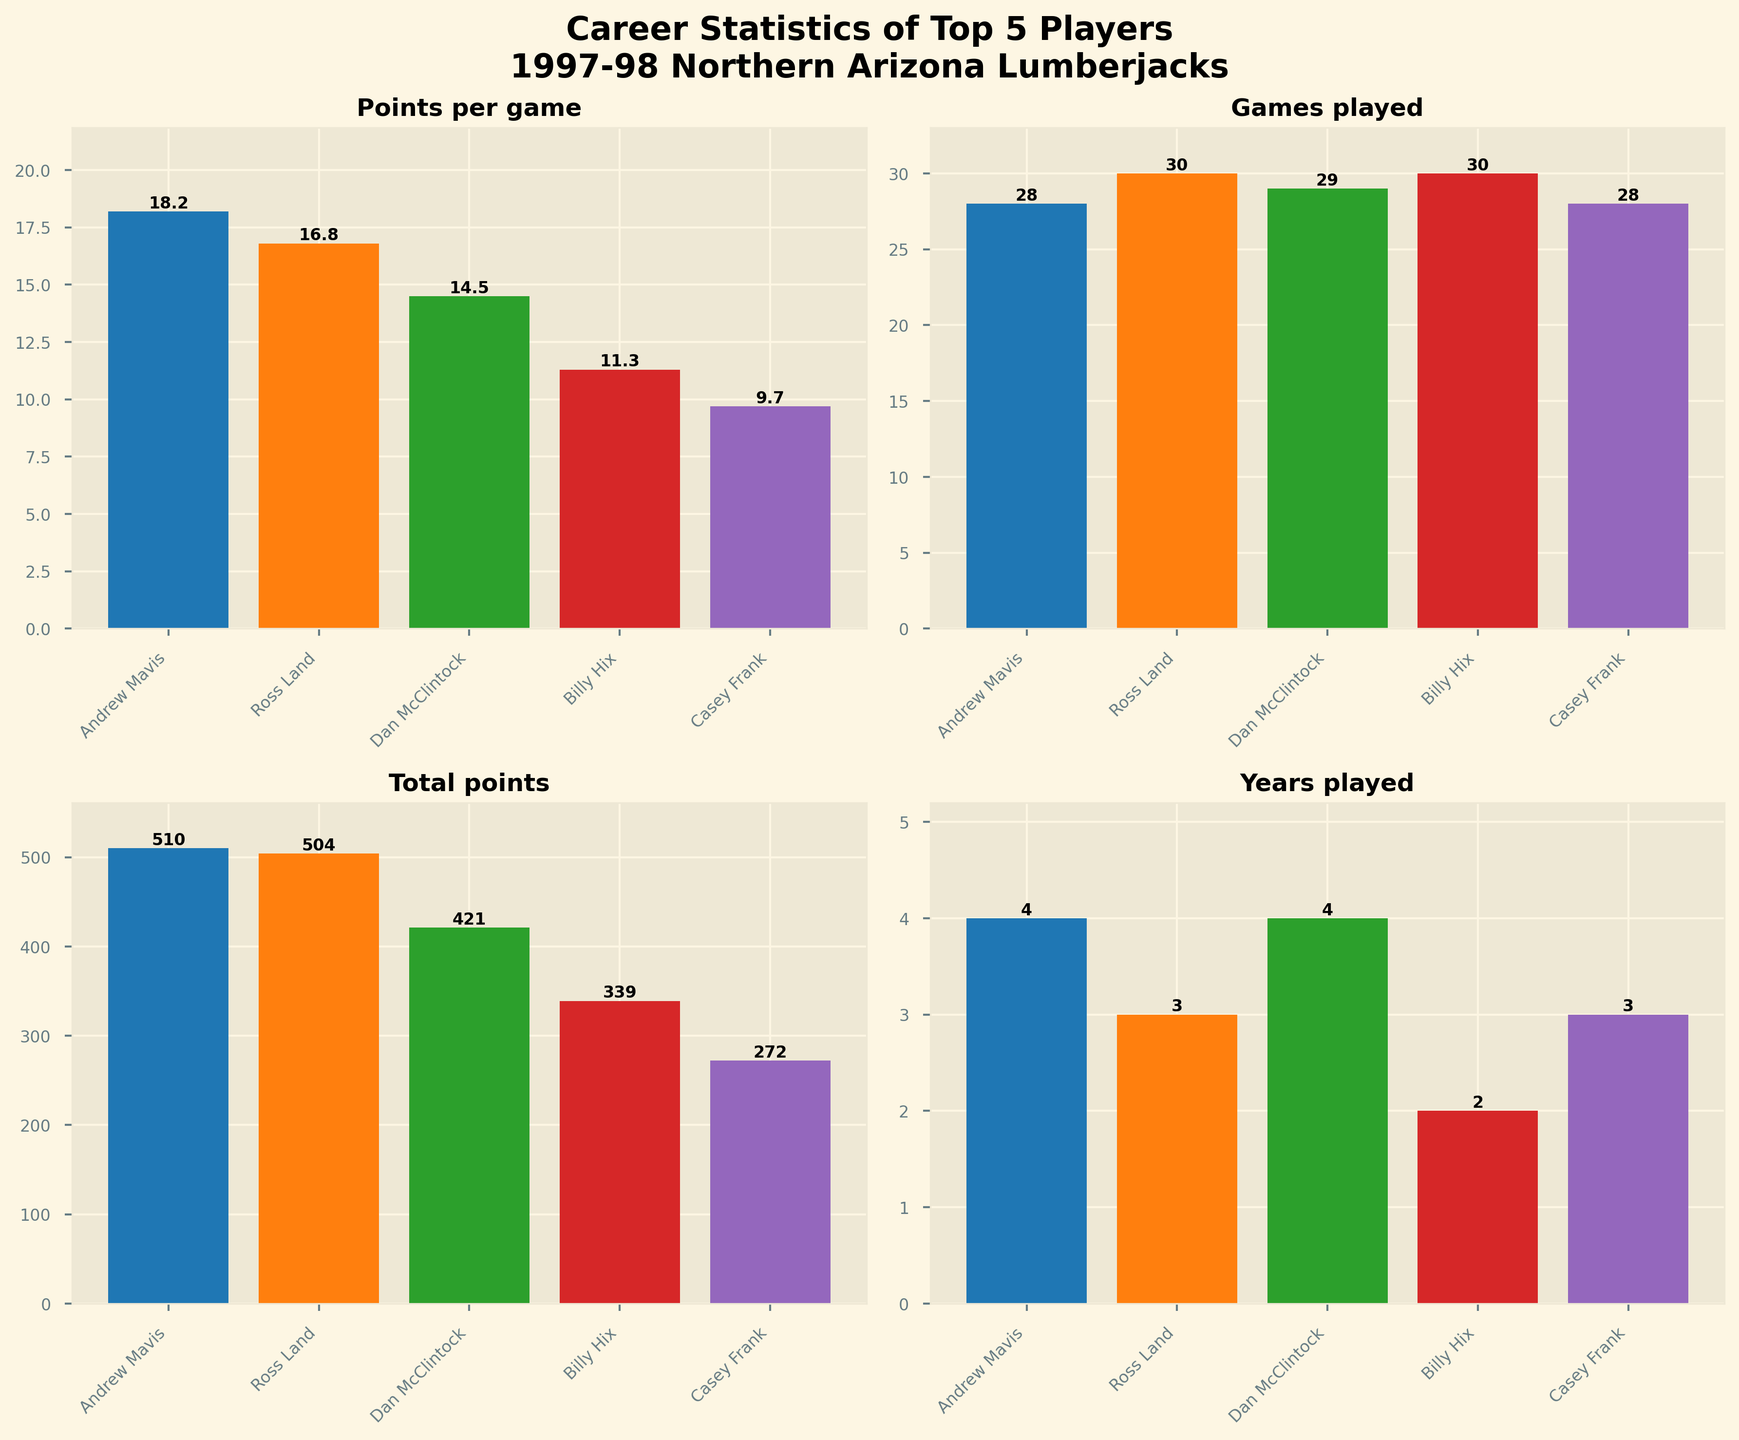What is the title of the figure? The title is usually located at the top of the figure. By looking at the figure, we can see large, bold text indicating the overall topic.
Answer: Career Statistics of Top 5 Players\n1997-98 Northern Arizona Lumberjacks Which player has the highest Points per game? Identify the bar that reaches the highest value in the "Points per game" subplot. The player name on the x-axis corresponding to this bar is the answer.
Answer: Andrew Mavis How many Games played did Ross Land play? In the "Games played" subplot, find the bar representing Ross Land and look at the number inside or on top of the bar to determine the count.
Answer: 30 What is the total number of points scored by Casey Frank? Look at the "Total points" subplot, identify the bar for Casey Frank and read the number displayed either inside or on top of the bar.
Answer: 272 Compare the Years played by Dan McClintock and Billy Hix. Who played more years? In the "Years played" subplot, compare the height of the bars for Dan McClintock and Billy Hix. The taller bar indicates who played more years.
Answer: Dan McClintock How many more Total points does Andrew Mavis have compared to Casey Frank? Subtract the Total points of Casey Frank from Andrew Mavis: 510 - 272.
Answer: 238 Calculate the average Points per game of all players. Sum the Points per game of all players (18.2 + 16.8 + 14.5 + 11.3 + 9.7) and divide by the number of players (5).
Answer: 14.1 Which subplot indicates years played by each player? Identify the subplot with the title "Years played". This can be found by reading the titles of each of the subplots.
Answer: The bottom-right subplot List the Players in descending order of their Points per game. In the "Points per game" subplot, order the bars from tallest to shortest and list the corresponding player names.
Answer: Andrew Mavis, Ross Land, Dan McClintock, Billy Hix, Casey Frank 